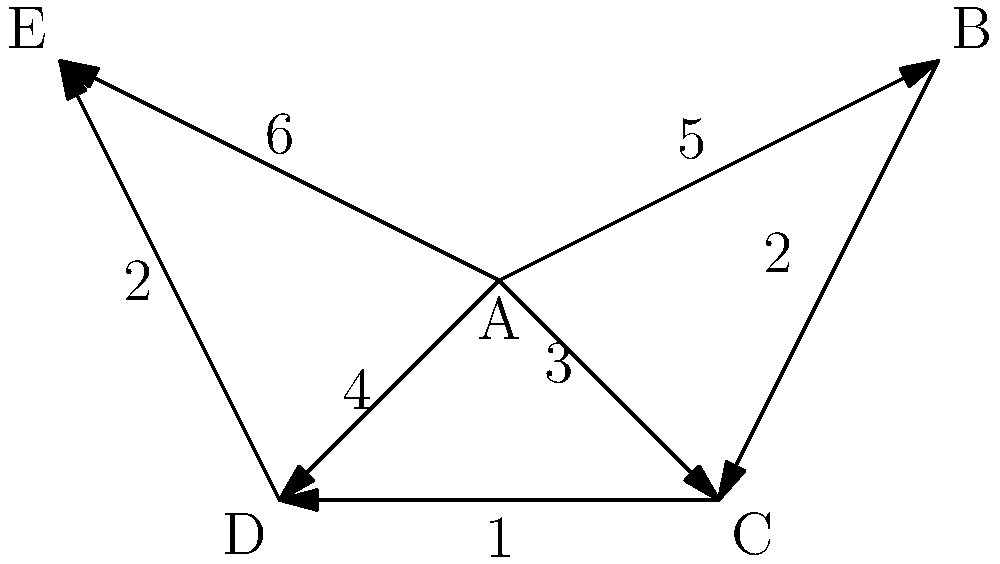As a seasoned sales manager, you're tasked with optimizing the distribution network for a new product line. The diagram represents potential distribution centers (nodes) and transportation routes (edges) with associated costs. What is the minimum cost to connect all distribution centers while ensuring efficient product flow? To find the minimum cost to connect all distribution centers, we need to identify the Minimum Spanning Tree (MST) of the given network. Let's use Kruskal's algorithm to solve this problem:

1. Sort all edges by weight in ascending order:
   CD (1), BC (2), DE (2), AC (3), AD (4), AB (5), AE (6)

2. Start with an empty set and add edges, ensuring no cycles are formed:
   - Add CD (1)
   - Add BC (2)
   - Add DE (2)
   - Add AC (3)

3. At this point, we have connected all nodes (A-B-C-D-E) without forming any cycles.

4. The MST includes edges: CD, BC, DE, and AC.

5. Calculate the total cost:
   Cost = 1 + 2 + 2 + 3 = 8

Therefore, the minimum cost to connect all distribution centers while ensuring efficient product flow is 8 units.
Answer: 8 units 